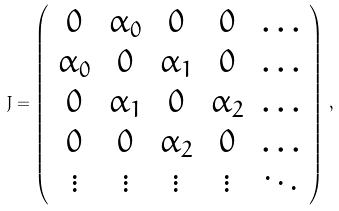Convert formula to latex. <formula><loc_0><loc_0><loc_500><loc_500>J = \left ( \begin{array} { c c c c c } 0 & \alpha _ { 0 } & 0 & 0 & \dots \\ \alpha _ { 0 } & 0 & \alpha _ { 1 } & 0 & \dots \\ 0 & \alpha _ { 1 } & 0 & \alpha _ { 2 } & \dots \\ 0 & 0 & \alpha _ { 2 } & 0 & \dots \\ \vdots & \vdots & \vdots & \vdots & \ddots \end{array} \right ) \, ,</formula> 